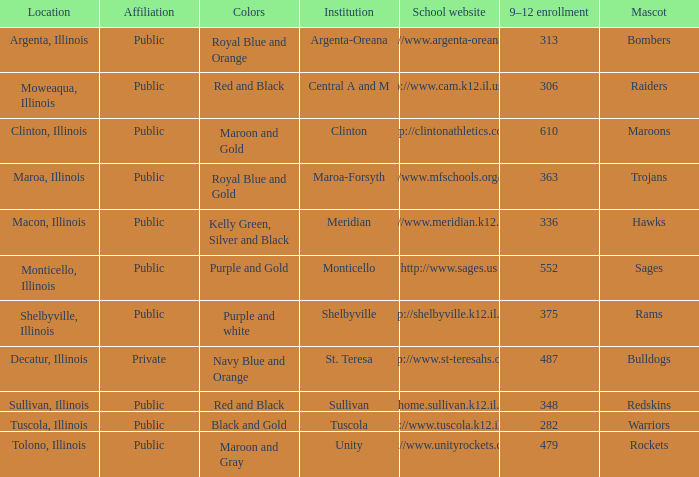What colors can you see players from Tolono, Illinois wearing? Maroon and Gray. 